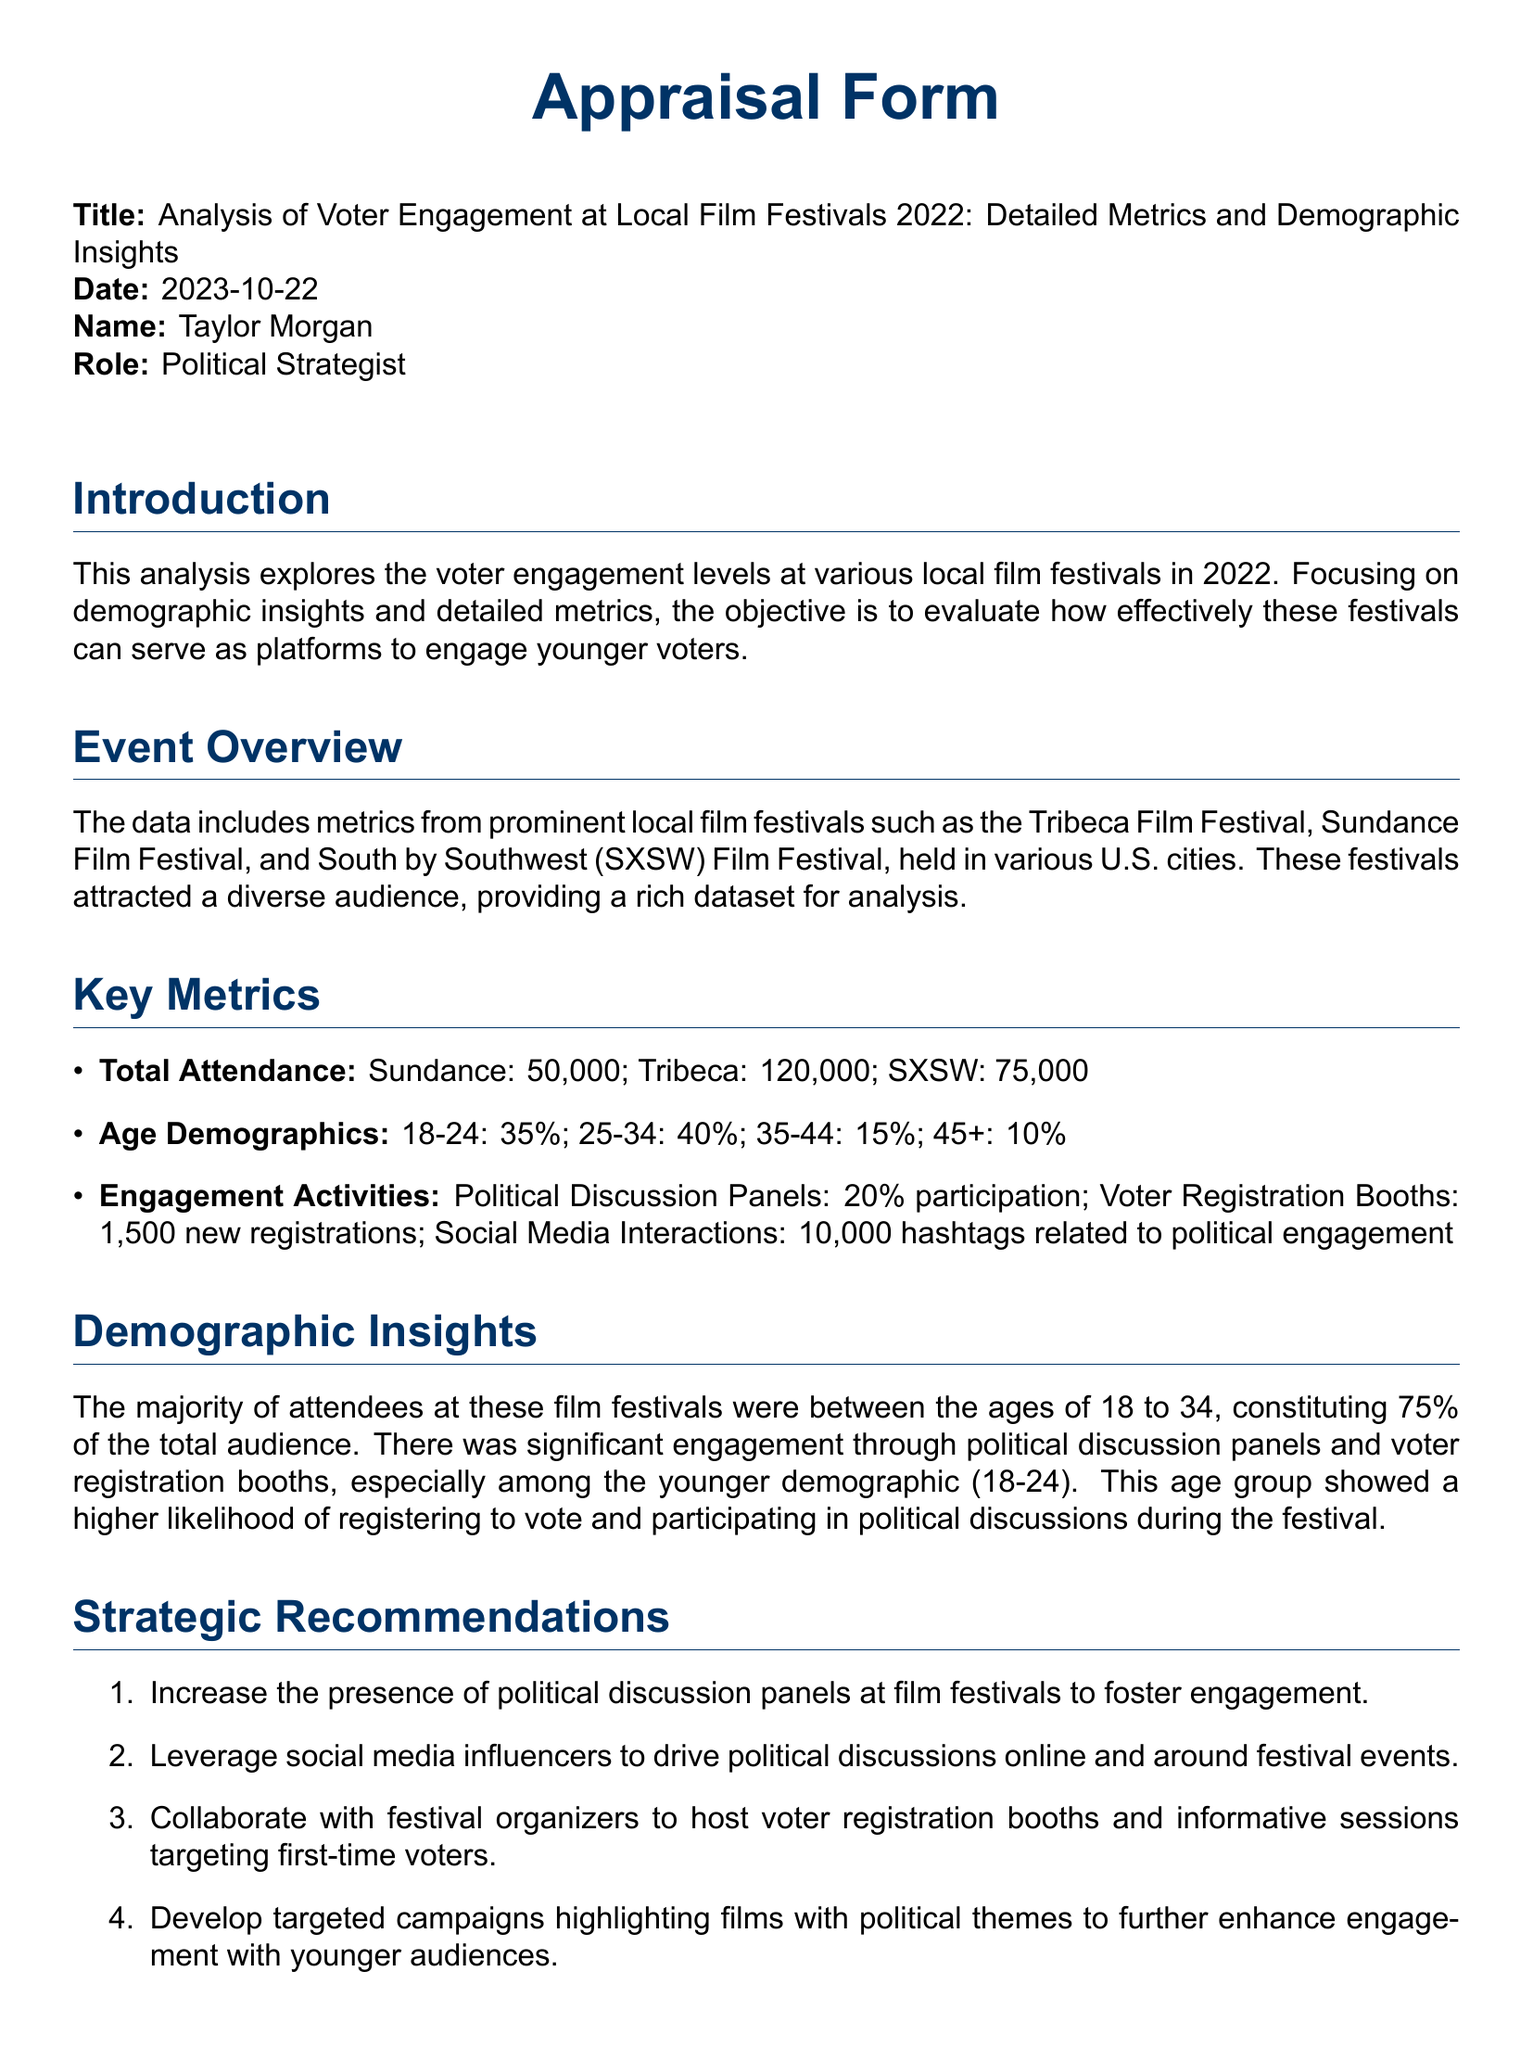what is the total attendance at Sundance Film Festival? The total attendance is explicitly stated in the document for Sundance Film Festival, which is 50,000.
Answer: 50,000 what percentage of attendees were aged 18-24? The document provides the age demographics, indicating that 35% of attendees were in the 18-24 age group.
Answer: 35% how many new voter registrations were recorded at the festivals? The document mentions that there were 1,500 new registrations at voter registration booths during the festivals.
Answer: 1,500 what is the main recommendation regarding political discussion panels? The document suggests to increase the presence of political discussion panels at film festivals to foster engagement.
Answer: Increase presence which festival had the highest total attendance? The document indicates that Tribeca Film Festival had the highest attendance at 120,000.
Answer: Tribeca what percentage of attendees were aged 35 and older? The age demographics presented in the document show that 25% of attendees were aged 35 and older (15% for 35-44 and 10% for 45+).
Answer: 25% what social media interaction metric was mentioned? The document states that there were 10,000 hashtags related to political engagement during the festivals.
Answer: 10,000 hashtags what film festival is referenced in the analysis besides Sundance? The document includes Tribeca and SXSW Film Festivals in its analysis besides Sundance.
Answer: Tribeca and SXSW 